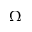<formula> <loc_0><loc_0><loc_500><loc_500>\Omega</formula> 